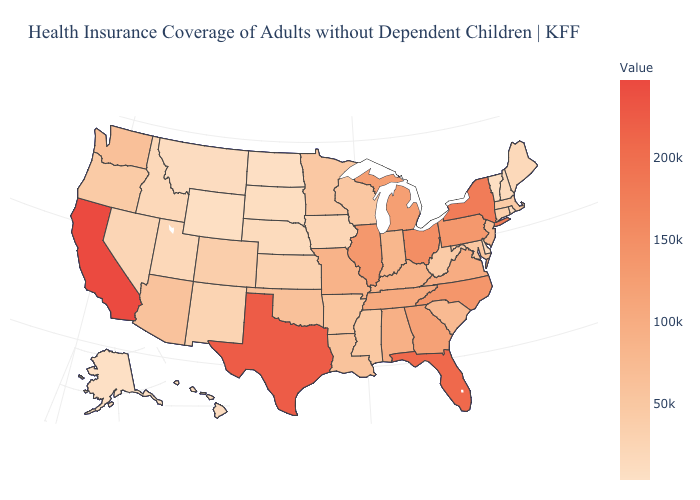Does California have the highest value in the USA?
Answer briefly. Yes. Is the legend a continuous bar?
Short answer required. Yes. Does Alaska have the lowest value in the West?
Concise answer only. Yes. Among the states that border Texas , does Oklahoma have the highest value?
Be succinct. Yes. Among the states that border Texas , which have the lowest value?
Answer briefly. New Mexico. Which states hav the highest value in the MidWest?
Short answer required. Ohio. 